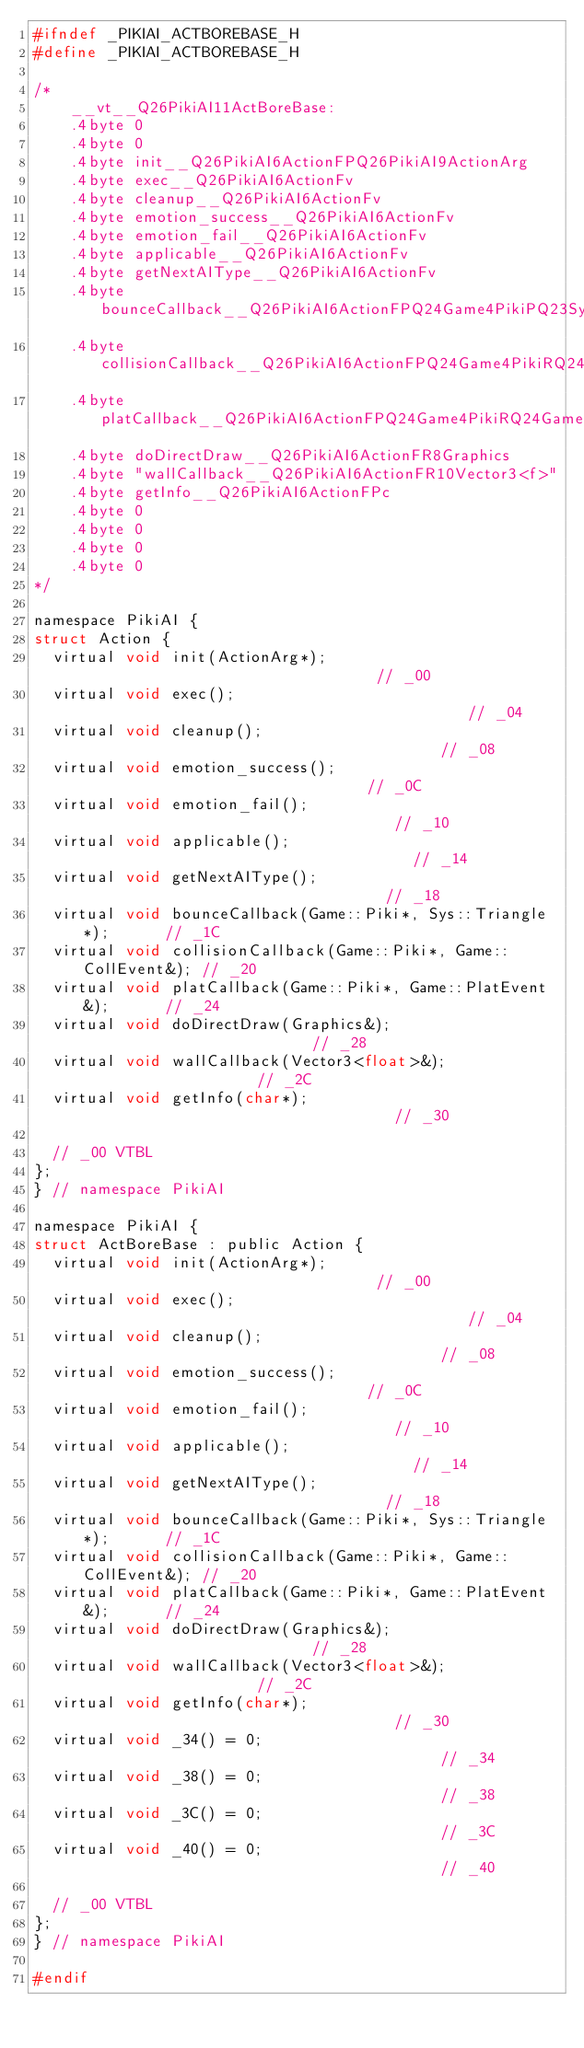<code> <loc_0><loc_0><loc_500><loc_500><_C_>#ifndef _PIKIAI_ACTBOREBASE_H
#define _PIKIAI_ACTBOREBASE_H

/*
    __vt__Q26PikiAI11ActBoreBase:
    .4byte 0
    .4byte 0
    .4byte init__Q26PikiAI6ActionFPQ26PikiAI9ActionArg
    .4byte exec__Q26PikiAI6ActionFv
    .4byte cleanup__Q26PikiAI6ActionFv
    .4byte emotion_success__Q26PikiAI6ActionFv
    .4byte emotion_fail__Q26PikiAI6ActionFv
    .4byte applicable__Q26PikiAI6ActionFv
    .4byte getNextAIType__Q26PikiAI6ActionFv
    .4byte bounceCallback__Q26PikiAI6ActionFPQ24Game4PikiPQ23Sys8Triangle
    .4byte collisionCallback__Q26PikiAI6ActionFPQ24Game4PikiRQ24Game9CollEvent
    .4byte platCallback__Q26PikiAI6ActionFPQ24Game4PikiRQ24Game9PlatEvent
    .4byte doDirectDraw__Q26PikiAI6ActionFR8Graphics
    .4byte "wallCallback__Q26PikiAI6ActionFR10Vector3<f>"
    .4byte getInfo__Q26PikiAI6ActionFPc
    .4byte 0
    .4byte 0
    .4byte 0
    .4byte 0
*/

namespace PikiAI {
struct Action {
	virtual void init(ActionArg*);                                 // _00
	virtual void exec();                                           // _04
	virtual void cleanup();                                        // _08
	virtual void emotion_success();                                // _0C
	virtual void emotion_fail();                                   // _10
	virtual void applicable();                                     // _14
	virtual void getNextAIType();                                  // _18
	virtual void bounceCallback(Game::Piki*, Sys::Triangle*);      // _1C
	virtual void collisionCallback(Game::Piki*, Game::CollEvent&); // _20
	virtual void platCallback(Game::Piki*, Game::PlatEvent&);      // _24
	virtual void doDirectDraw(Graphics&);                          // _28
	virtual void wallCallback(Vector3<float>&);                    // _2C
	virtual void getInfo(char*);                                   // _30

	// _00 VTBL
};
} // namespace PikiAI

namespace PikiAI {
struct ActBoreBase : public Action {
	virtual void init(ActionArg*);                                 // _00
	virtual void exec();                                           // _04
	virtual void cleanup();                                        // _08
	virtual void emotion_success();                                // _0C
	virtual void emotion_fail();                                   // _10
	virtual void applicable();                                     // _14
	virtual void getNextAIType();                                  // _18
	virtual void bounceCallback(Game::Piki*, Sys::Triangle*);      // _1C
	virtual void collisionCallback(Game::Piki*, Game::CollEvent&); // _20
	virtual void platCallback(Game::Piki*, Game::PlatEvent&);      // _24
	virtual void doDirectDraw(Graphics&);                          // _28
	virtual void wallCallback(Vector3<float>&);                    // _2C
	virtual void getInfo(char*);                                   // _30
	virtual void _34() = 0;                                        // _34
	virtual void _38() = 0;                                        // _38
	virtual void _3C() = 0;                                        // _3C
	virtual void _40() = 0;                                        // _40

	// _00 VTBL
};
} // namespace PikiAI

#endif
</code> 